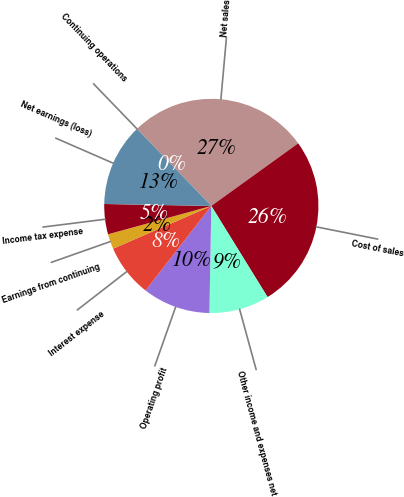Convert chart to OTSL. <chart><loc_0><loc_0><loc_500><loc_500><pie_chart><fcel>Net sales<fcel>Cost of sales<fcel>Other income and expenses net<fcel>Operating profit<fcel>Interest expense<fcel>Earnings from continuing<fcel>Income tax expense<fcel>Net earnings (loss)<fcel>Continuing operations<nl><fcel>27.27%<fcel>26.14%<fcel>9.09%<fcel>10.23%<fcel>7.95%<fcel>2.27%<fcel>4.55%<fcel>12.5%<fcel>0.0%<nl></chart> 